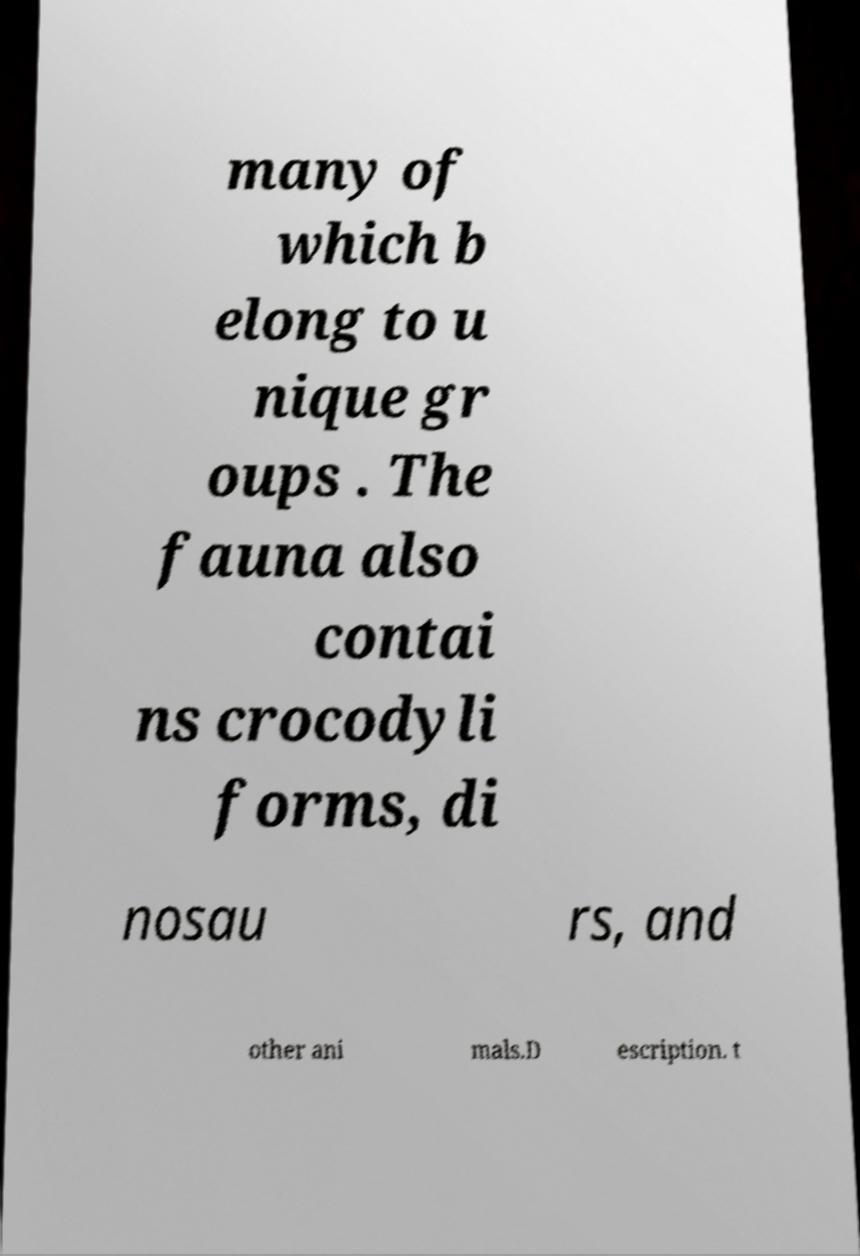Could you extract and type out the text from this image? many of which b elong to u nique gr oups . The fauna also contai ns crocodyli forms, di nosau rs, and other ani mals.D escription. t 